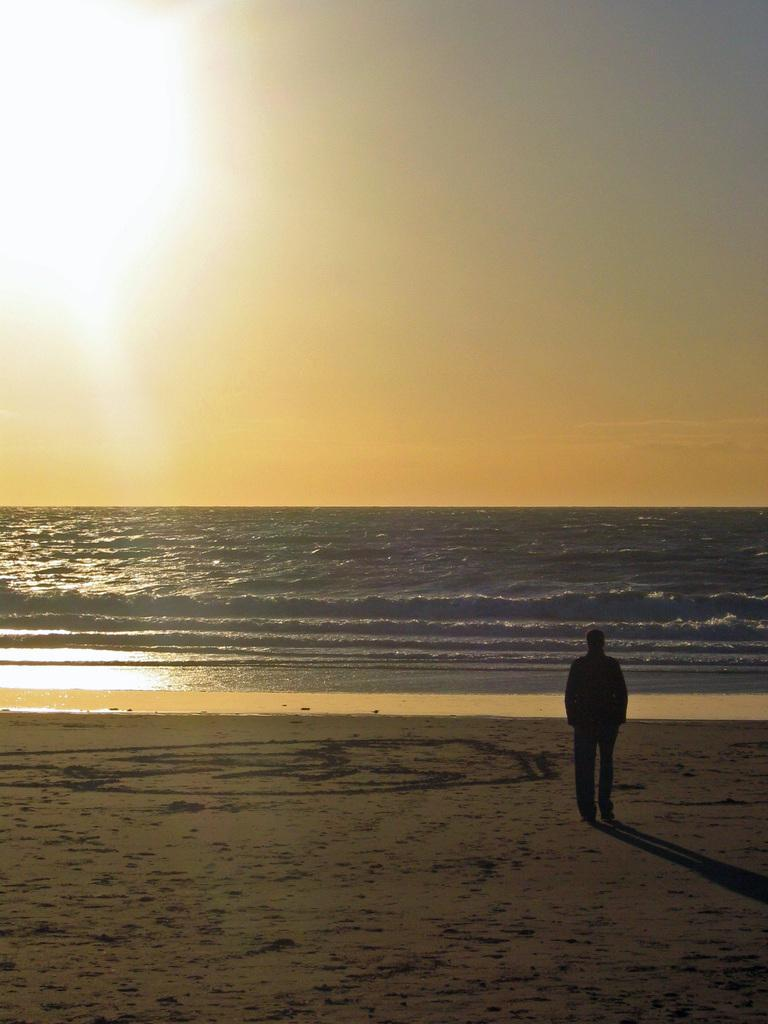What is the person in the image standing on? The person is standing on the sand. What can be seen in the background of the image? The background of the image includes water. What is happening in the sky in the image? The top of the image features a sunrise. What else is visible in the image besides the person and the water? The sky is visible in the image. How much does the paste weigh in the image? There is no paste present in the image, so it cannot be weighed. How many children are playing in the water in the image? There are no children present in the image; it only features a person standing on the sand. 